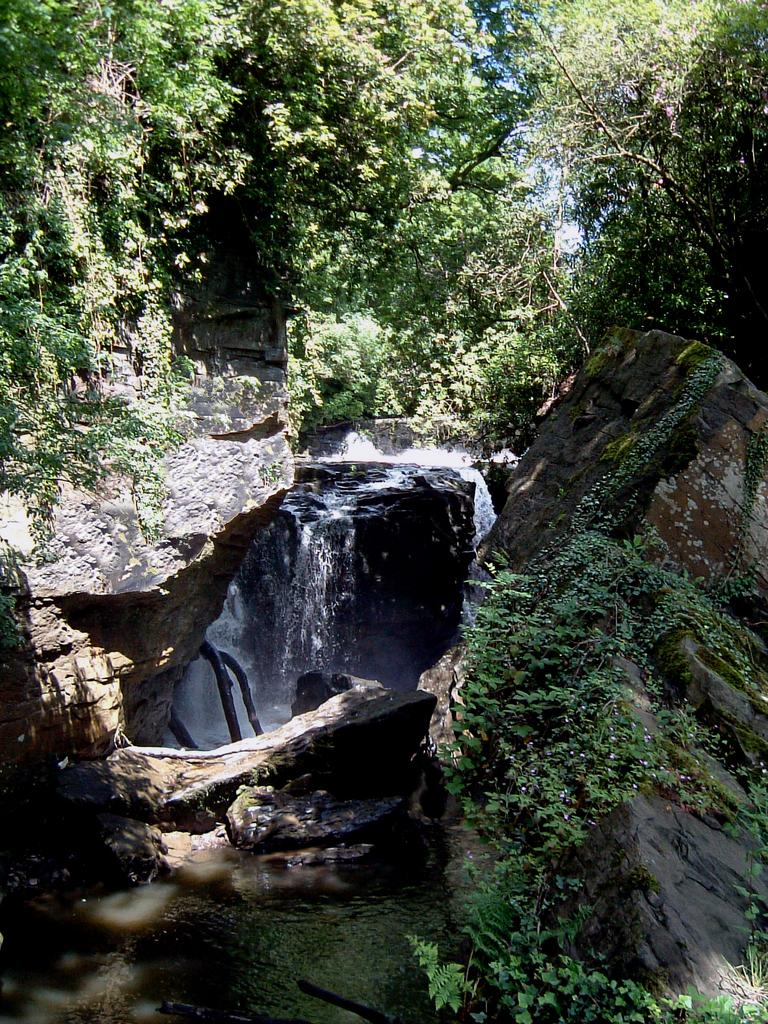What type of natural features can be seen in the image? There are trees, rocks, and a waterfall visible in the image. What is located at the bottom of the image? There are plants and water visible at the bottom of the image. What type of door can be seen in the image? There is no door present in the image; it features natural elements such as trees, rocks, and a waterfall. What type of stamp is visible on the waterfall in the image? There is no stamp present on the waterfall in the image; it is a natural feature. 